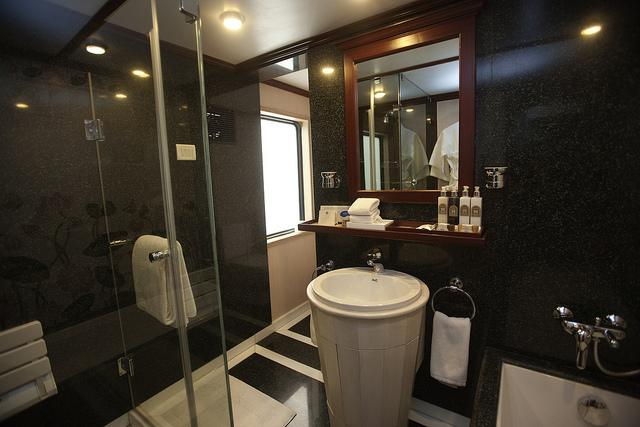What shape is the mirror hanging on the wall with some wooden planks? Please explain your reasoning. rectangle. The mirror is not curved. it does not have equal sides. 